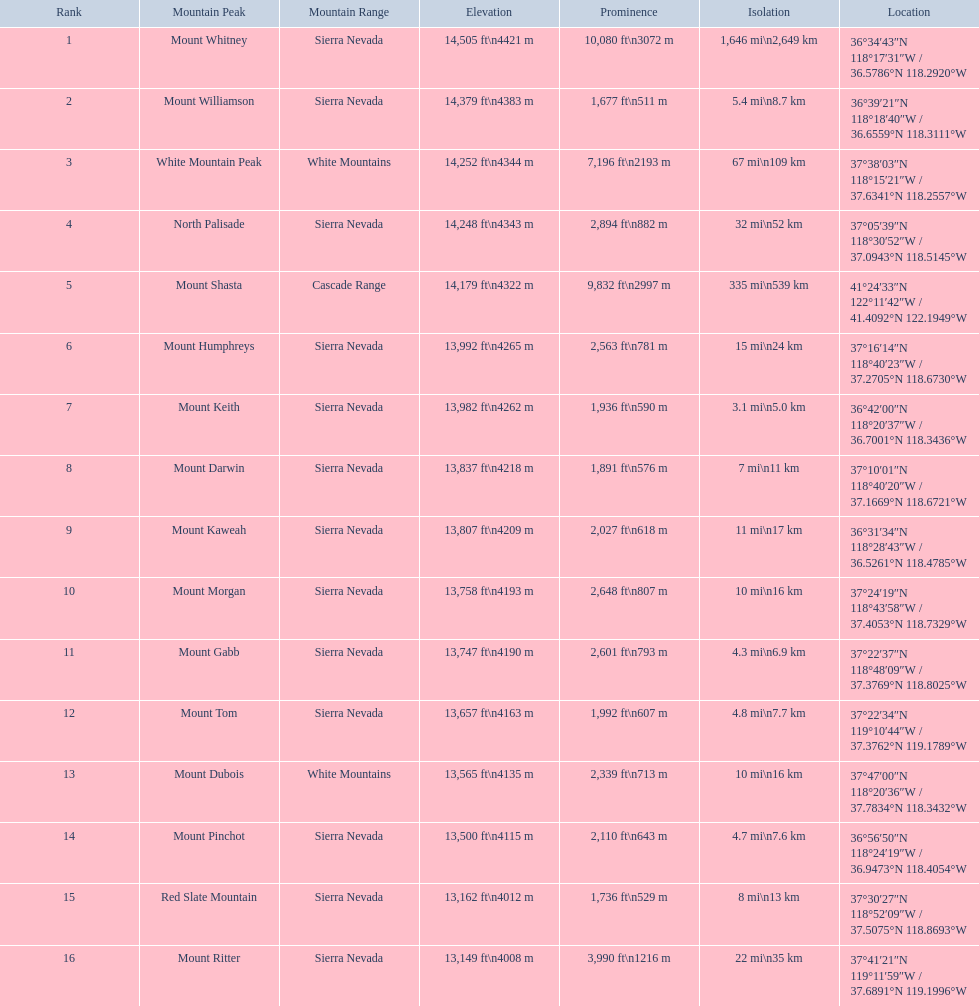Which mountain peak is no higher than 13,149 ft? Mount Ritter. 